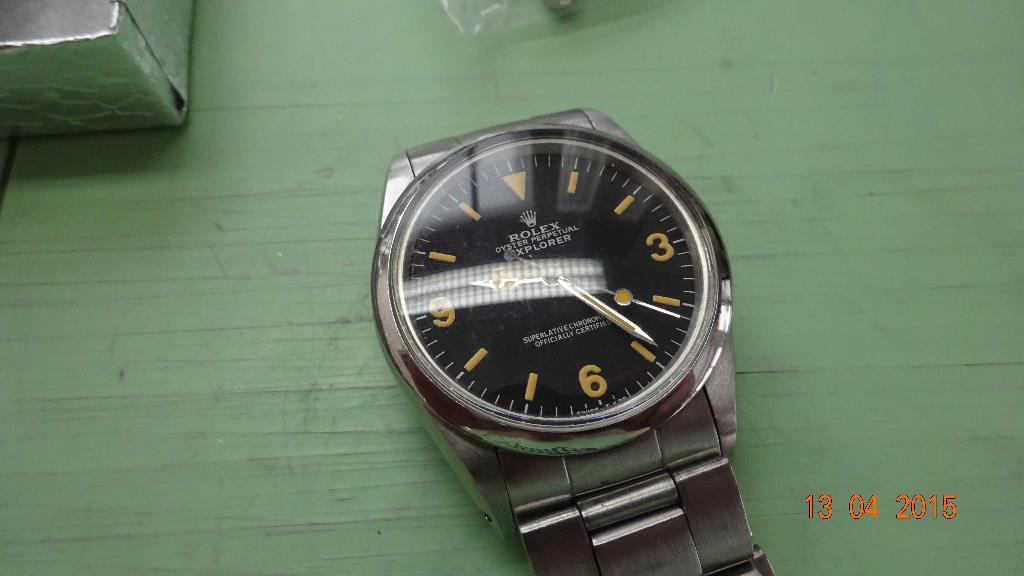<image>
Summarize the visual content of the image. A vintage looking Rolex watch on a green table. 